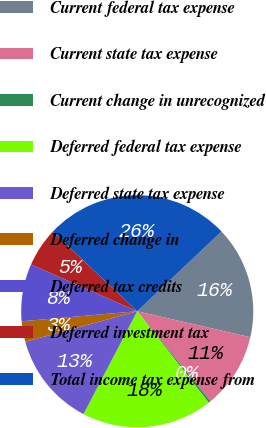Convert chart to OTSL. <chart><loc_0><loc_0><loc_500><loc_500><pie_chart><fcel>Current federal tax expense<fcel>Current state tax expense<fcel>Current change in unrecognized<fcel>Deferred federal tax expense<fcel>Deferred state tax expense<fcel>Deferred change in<fcel>Deferred tax credits<fcel>Deferred investment tax<fcel>Total income tax expense from<nl><fcel>15.66%<fcel>10.54%<fcel>0.3%<fcel>18.23%<fcel>13.1%<fcel>2.86%<fcel>7.98%<fcel>5.42%<fcel>25.91%<nl></chart> 